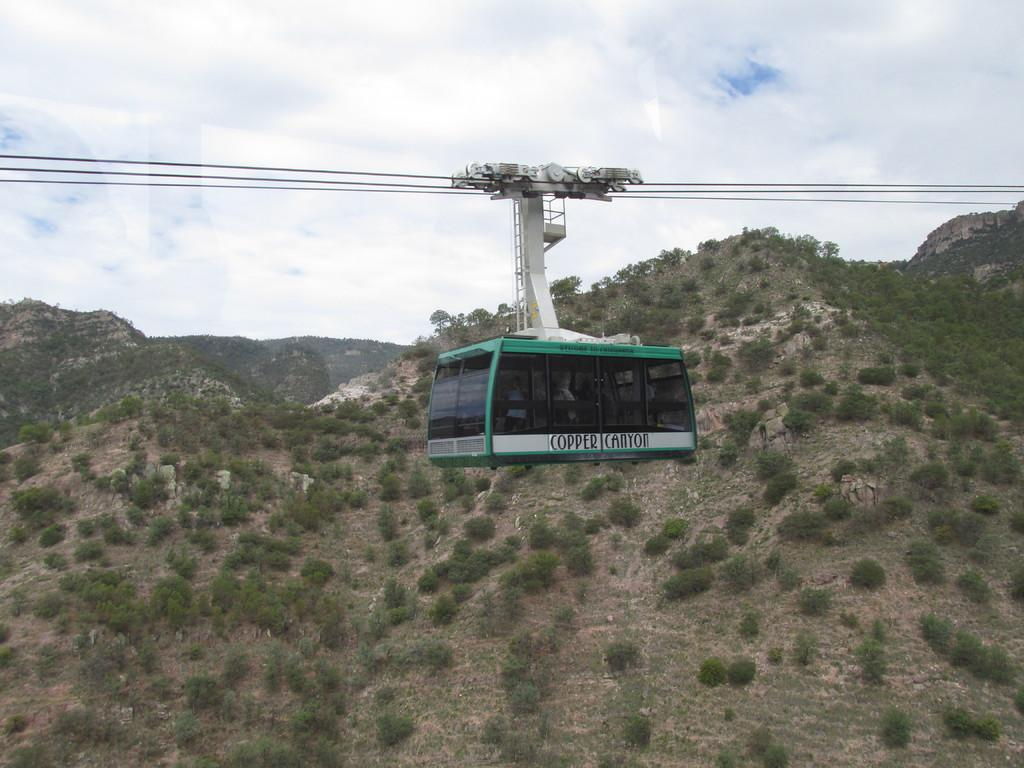What type of transportation is shown in the image? There is a ropeway in the image. What natural features can be seen in the background? There are mountains and trees in the image. How would you describe the weather in the image? The sky is cloudy in the image. What date is marked on the calendar in the image? There is no calendar present in the image. 